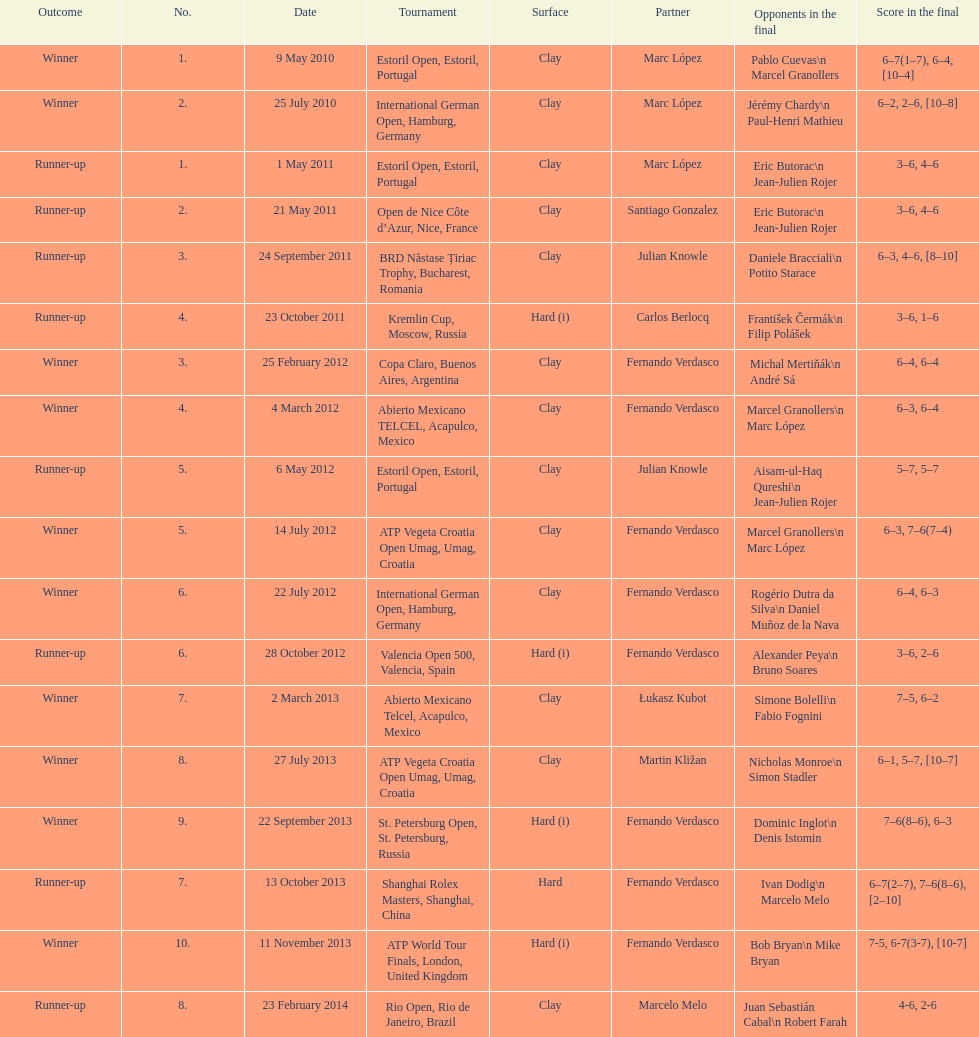What is the number of winning outcomes? 10. Write the full table. {'header': ['Outcome', 'No.', 'Date', 'Tournament', 'Surface', 'Partner', 'Opponents in the final', 'Score in the final'], 'rows': [['Winner', '1.', '9 May 2010', 'Estoril Open, Estoril, Portugal', 'Clay', 'Marc López', 'Pablo Cuevas\\n Marcel Granollers', '6–7(1–7), 6–4, [10–4]'], ['Winner', '2.', '25 July 2010', 'International German Open, Hamburg, Germany', 'Clay', 'Marc López', 'Jérémy Chardy\\n Paul-Henri Mathieu', '6–2, 2–6, [10–8]'], ['Runner-up', '1.', '1 May 2011', 'Estoril Open, Estoril, Portugal', 'Clay', 'Marc López', 'Eric Butorac\\n Jean-Julien Rojer', '3–6, 4–6'], ['Runner-up', '2.', '21 May 2011', 'Open de Nice Côte d’Azur, Nice, France', 'Clay', 'Santiago Gonzalez', 'Eric Butorac\\n Jean-Julien Rojer', '3–6, 4–6'], ['Runner-up', '3.', '24 September 2011', 'BRD Năstase Țiriac Trophy, Bucharest, Romania', 'Clay', 'Julian Knowle', 'Daniele Bracciali\\n Potito Starace', '6–3, 4–6, [8–10]'], ['Runner-up', '4.', '23 October 2011', 'Kremlin Cup, Moscow, Russia', 'Hard (i)', 'Carlos Berlocq', 'František Čermák\\n Filip Polášek', '3–6, 1–6'], ['Winner', '3.', '25 February 2012', 'Copa Claro, Buenos Aires, Argentina', 'Clay', 'Fernando Verdasco', 'Michal Mertiňák\\n André Sá', '6–4, 6–4'], ['Winner', '4.', '4 March 2012', 'Abierto Mexicano TELCEL, Acapulco, Mexico', 'Clay', 'Fernando Verdasco', 'Marcel Granollers\\n Marc López', '6–3, 6–4'], ['Runner-up', '5.', '6 May 2012', 'Estoril Open, Estoril, Portugal', 'Clay', 'Julian Knowle', 'Aisam-ul-Haq Qureshi\\n Jean-Julien Rojer', '5–7, 5–7'], ['Winner', '5.', '14 July 2012', 'ATP Vegeta Croatia Open Umag, Umag, Croatia', 'Clay', 'Fernando Verdasco', 'Marcel Granollers\\n Marc López', '6–3, 7–6(7–4)'], ['Winner', '6.', '22 July 2012', 'International German Open, Hamburg, Germany', 'Clay', 'Fernando Verdasco', 'Rogério Dutra da Silva\\n Daniel Muñoz de la Nava', '6–4, 6–3'], ['Runner-up', '6.', '28 October 2012', 'Valencia Open 500, Valencia, Spain', 'Hard (i)', 'Fernando Verdasco', 'Alexander Peya\\n Bruno Soares', '3–6, 2–6'], ['Winner', '7.', '2 March 2013', 'Abierto Mexicano Telcel, Acapulco, Mexico', 'Clay', 'Łukasz Kubot', 'Simone Bolelli\\n Fabio Fognini', '7–5, 6–2'], ['Winner', '8.', '27 July 2013', 'ATP Vegeta Croatia Open Umag, Umag, Croatia', 'Clay', 'Martin Kližan', 'Nicholas Monroe\\n Simon Stadler', '6–1, 5–7, [10–7]'], ['Winner', '9.', '22 September 2013', 'St. Petersburg Open, St. Petersburg, Russia', 'Hard (i)', 'Fernando Verdasco', 'Dominic Inglot\\n Denis Istomin', '7–6(8–6), 6–3'], ['Runner-up', '7.', '13 October 2013', 'Shanghai Rolex Masters, Shanghai, China', 'Hard', 'Fernando Verdasco', 'Ivan Dodig\\n Marcelo Melo', '6–7(2–7), 7–6(8–6), [2–10]'], ['Winner', '10.', '11 November 2013', 'ATP World Tour Finals, London, United Kingdom', 'Hard (i)', 'Fernando Verdasco', 'Bob Bryan\\n Mike Bryan', '7-5, 6-7(3-7), [10-7]'], ['Runner-up', '8.', '23 February 2014', 'Rio Open, Rio de Janeiro, Brazil', 'Clay', 'Marcelo Melo', 'Juan Sebastián Cabal\\n Robert Farah', '4-6, 2-6']]} 